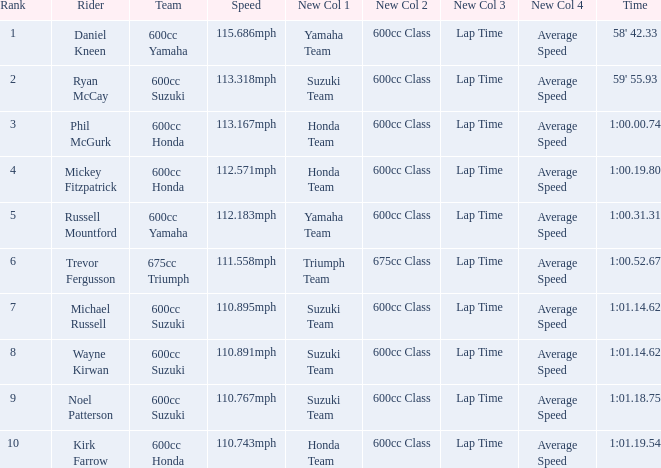I'm looking to parse the entire table for insights. Could you assist me with that? {'header': ['Rank', 'Rider', 'Team', 'Speed', 'New Col 1', 'New Col 2', 'New Col 3', 'New Col 4', 'Time'], 'rows': [['1', 'Daniel Kneen', '600cc Yamaha', '115.686mph', 'Yamaha Team', '600cc Class', 'Lap Time', 'Average Speed', "58' 42.33"], ['2', 'Ryan McCay', '600cc Suzuki', '113.318mph', 'Suzuki Team', '600cc Class', 'Lap Time', 'Average Speed', "59' 55.93"], ['3', 'Phil McGurk', '600cc Honda', '113.167mph', 'Honda Team', '600cc Class', 'Lap Time', 'Average Speed', '1:00.00.74'], ['4', 'Mickey Fitzpatrick', '600cc Honda', '112.571mph', 'Honda Team', '600cc Class', 'Lap Time', 'Average Speed', '1:00.19.80'], ['5', 'Russell Mountford', '600cc Yamaha', '112.183mph', 'Yamaha Team', '600cc Class', 'Lap Time', 'Average Speed', '1:00.31.31'], ['6', 'Trevor Fergusson', '675cc Triumph', '111.558mph', 'Triumph Team', '675cc Class', 'Lap Time', 'Average Speed', '1:00.52.67'], ['7', 'Michael Russell', '600cc Suzuki', '110.895mph', 'Suzuki Team', '600cc Class', 'Lap Time', 'Average Speed', '1:01.14.62'], ['8', 'Wayne Kirwan', '600cc Suzuki', '110.891mph', 'Suzuki Team', '600cc Class', 'Lap Time', 'Average Speed', '1:01.14.62'], ['9', 'Noel Patterson', '600cc Suzuki', '110.767mph', 'Suzuki Team', '600cc Class', 'Lap Time', 'Average Speed', '1:01.18.75'], ['10', 'Kirk Farrow', '600cc Honda', '110.743mph', 'Honda Team', '600cc Class', 'Lap Time', 'Average Speed', '1:01.19.54']]} How many ranks have 1:01.14.62 as the time, with michael russell as the rider? 1.0. 